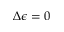<formula> <loc_0><loc_0><loc_500><loc_500>\Delta \epsilon = 0</formula> 